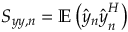<formula> <loc_0><loc_0><loc_500><loc_500>S _ { y y , n } = \mathbb { E } \left ( \hat { y } _ { n } \hat { y } _ { n } ^ { H } \right )</formula> 